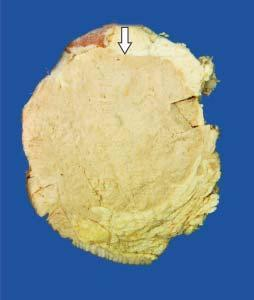does cut surface of the breast show a large grey white soft fleshy tumour replacing almost whole of the breast?
Answer the question using a single word or phrase. Yes 